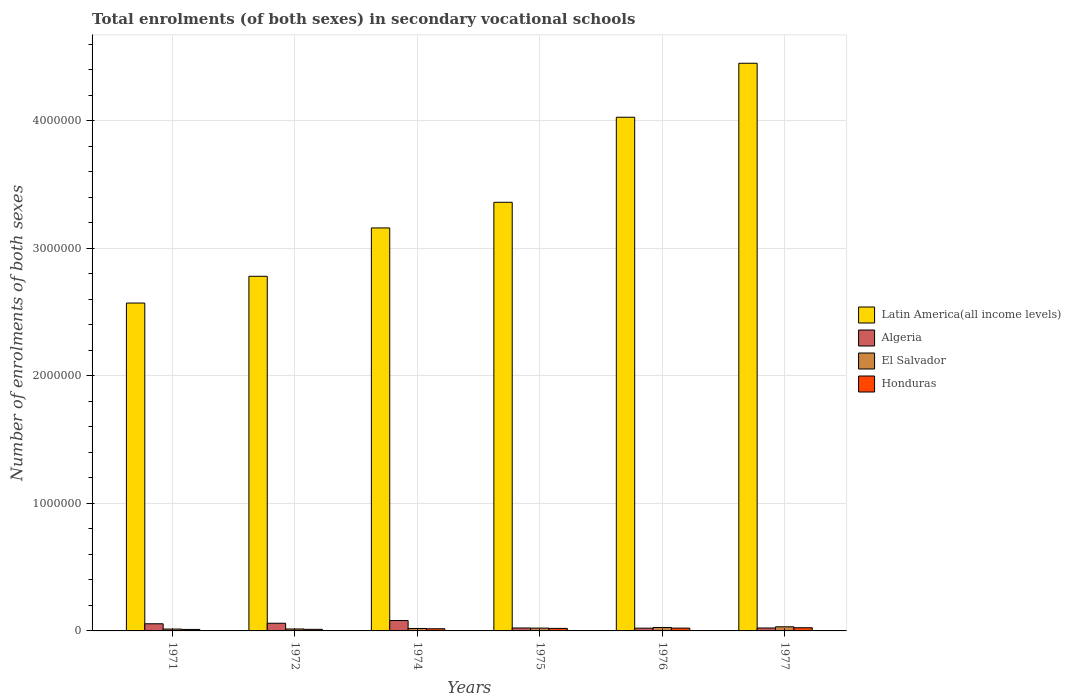How many groups of bars are there?
Your answer should be very brief. 6. How many bars are there on the 4th tick from the left?
Your answer should be compact. 4. What is the label of the 6th group of bars from the left?
Your response must be concise. 1977. In how many cases, is the number of bars for a given year not equal to the number of legend labels?
Keep it short and to the point. 0. What is the number of enrolments in secondary schools in Algeria in 1974?
Make the answer very short. 8.15e+04. Across all years, what is the maximum number of enrolments in secondary schools in El Salvador?
Provide a short and direct response. 3.22e+04. Across all years, what is the minimum number of enrolments in secondary schools in Honduras?
Keep it short and to the point. 1.16e+04. In which year was the number of enrolments in secondary schools in El Salvador maximum?
Make the answer very short. 1977. In which year was the number of enrolments in secondary schools in Honduras minimum?
Your answer should be compact. 1971. What is the total number of enrolments in secondary schools in Latin America(all income levels) in the graph?
Make the answer very short. 2.04e+07. What is the difference between the number of enrolments in secondary schools in Algeria in 1975 and that in 1976?
Your answer should be compact. 1509. What is the difference between the number of enrolments in secondary schools in Latin America(all income levels) in 1975 and the number of enrolments in secondary schools in Honduras in 1974?
Ensure brevity in your answer.  3.34e+06. What is the average number of enrolments in secondary schools in Honduras per year?
Offer a very short reply. 1.80e+04. In the year 1975, what is the difference between the number of enrolments in secondary schools in Honduras and number of enrolments in secondary schools in Latin America(all income levels)?
Your answer should be very brief. -3.34e+06. What is the ratio of the number of enrolments in secondary schools in Honduras in 1972 to that in 1977?
Give a very brief answer. 0.5. Is the difference between the number of enrolments in secondary schools in Honduras in 1972 and 1976 greater than the difference between the number of enrolments in secondary schools in Latin America(all income levels) in 1972 and 1976?
Offer a terse response. Yes. What is the difference between the highest and the second highest number of enrolments in secondary schools in Honduras?
Your response must be concise. 2913. What is the difference between the highest and the lowest number of enrolments in secondary schools in El Salvador?
Keep it short and to the point. 1.76e+04. Is the sum of the number of enrolments in secondary schools in Honduras in 1974 and 1976 greater than the maximum number of enrolments in secondary schools in El Salvador across all years?
Keep it short and to the point. Yes. What does the 2nd bar from the left in 1976 represents?
Your response must be concise. Algeria. What does the 2nd bar from the right in 1972 represents?
Offer a terse response. El Salvador. Is it the case that in every year, the sum of the number of enrolments in secondary schools in Latin America(all income levels) and number of enrolments in secondary schools in Algeria is greater than the number of enrolments in secondary schools in Honduras?
Your answer should be very brief. Yes. How many years are there in the graph?
Offer a terse response. 6. Are the values on the major ticks of Y-axis written in scientific E-notation?
Your answer should be very brief. No. Where does the legend appear in the graph?
Provide a succinct answer. Center right. How are the legend labels stacked?
Make the answer very short. Vertical. What is the title of the graph?
Offer a terse response. Total enrolments (of both sexes) in secondary vocational schools. Does "Lao PDR" appear as one of the legend labels in the graph?
Give a very brief answer. No. What is the label or title of the Y-axis?
Ensure brevity in your answer.  Number of enrolments of both sexes. What is the Number of enrolments of both sexes in Latin America(all income levels) in 1971?
Provide a short and direct response. 2.57e+06. What is the Number of enrolments of both sexes in Algeria in 1971?
Make the answer very short. 5.61e+04. What is the Number of enrolments of both sexes of El Salvador in 1971?
Your answer should be very brief. 1.47e+04. What is the Number of enrolments of both sexes of Honduras in 1971?
Your answer should be very brief. 1.16e+04. What is the Number of enrolments of both sexes in Latin America(all income levels) in 1972?
Your answer should be compact. 2.78e+06. What is the Number of enrolments of both sexes in Algeria in 1972?
Offer a very short reply. 6.02e+04. What is the Number of enrolments of both sexes of El Salvador in 1972?
Offer a very short reply. 1.52e+04. What is the Number of enrolments of both sexes of Honduras in 1972?
Your response must be concise. 1.25e+04. What is the Number of enrolments of both sexes in Latin America(all income levels) in 1974?
Your answer should be very brief. 3.16e+06. What is the Number of enrolments of both sexes in Algeria in 1974?
Offer a terse response. 8.15e+04. What is the Number of enrolments of both sexes in El Salvador in 1974?
Give a very brief answer. 1.91e+04. What is the Number of enrolments of both sexes of Honduras in 1974?
Provide a succinct answer. 1.70e+04. What is the Number of enrolments of both sexes of Latin America(all income levels) in 1975?
Your answer should be very brief. 3.36e+06. What is the Number of enrolments of both sexes in Algeria in 1975?
Your answer should be very brief. 2.31e+04. What is the Number of enrolments of both sexes of El Salvador in 1975?
Make the answer very short. 2.22e+04. What is the Number of enrolments of both sexes in Honduras in 1975?
Provide a succinct answer. 1.97e+04. What is the Number of enrolments of both sexes of Latin America(all income levels) in 1976?
Give a very brief answer. 4.03e+06. What is the Number of enrolments of both sexes of Algeria in 1976?
Offer a terse response. 2.16e+04. What is the Number of enrolments of both sexes of El Salvador in 1976?
Your answer should be compact. 2.66e+04. What is the Number of enrolments of both sexes of Honduras in 1976?
Offer a terse response. 2.20e+04. What is the Number of enrolments of both sexes of Latin America(all income levels) in 1977?
Offer a terse response. 4.45e+06. What is the Number of enrolments of both sexes of Algeria in 1977?
Make the answer very short. 2.30e+04. What is the Number of enrolments of both sexes in El Salvador in 1977?
Offer a very short reply. 3.22e+04. What is the Number of enrolments of both sexes in Honduras in 1977?
Your answer should be compact. 2.49e+04. Across all years, what is the maximum Number of enrolments of both sexes of Latin America(all income levels)?
Keep it short and to the point. 4.45e+06. Across all years, what is the maximum Number of enrolments of both sexes of Algeria?
Your answer should be compact. 8.15e+04. Across all years, what is the maximum Number of enrolments of both sexes in El Salvador?
Give a very brief answer. 3.22e+04. Across all years, what is the maximum Number of enrolments of both sexes in Honduras?
Offer a terse response. 2.49e+04. Across all years, what is the minimum Number of enrolments of both sexes of Latin America(all income levels)?
Keep it short and to the point. 2.57e+06. Across all years, what is the minimum Number of enrolments of both sexes in Algeria?
Offer a terse response. 2.16e+04. Across all years, what is the minimum Number of enrolments of both sexes of El Salvador?
Make the answer very short. 1.47e+04. Across all years, what is the minimum Number of enrolments of both sexes of Honduras?
Give a very brief answer. 1.16e+04. What is the total Number of enrolments of both sexes in Latin America(all income levels) in the graph?
Your response must be concise. 2.04e+07. What is the total Number of enrolments of both sexes in Algeria in the graph?
Your response must be concise. 2.66e+05. What is the total Number of enrolments of both sexes of El Salvador in the graph?
Your answer should be very brief. 1.30e+05. What is the total Number of enrolments of both sexes in Honduras in the graph?
Make the answer very short. 1.08e+05. What is the difference between the Number of enrolments of both sexes in Latin America(all income levels) in 1971 and that in 1972?
Provide a succinct answer. -2.10e+05. What is the difference between the Number of enrolments of both sexes in Algeria in 1971 and that in 1972?
Provide a succinct answer. -4174. What is the difference between the Number of enrolments of both sexes of El Salvador in 1971 and that in 1972?
Keep it short and to the point. -527. What is the difference between the Number of enrolments of both sexes of Honduras in 1971 and that in 1972?
Offer a terse response. -825. What is the difference between the Number of enrolments of both sexes in Latin America(all income levels) in 1971 and that in 1974?
Your response must be concise. -5.89e+05. What is the difference between the Number of enrolments of both sexes of Algeria in 1971 and that in 1974?
Provide a succinct answer. -2.54e+04. What is the difference between the Number of enrolments of both sexes in El Salvador in 1971 and that in 1974?
Provide a short and direct response. -4484. What is the difference between the Number of enrolments of both sexes of Honduras in 1971 and that in 1974?
Ensure brevity in your answer.  -5352. What is the difference between the Number of enrolments of both sexes in Latin America(all income levels) in 1971 and that in 1975?
Keep it short and to the point. -7.90e+05. What is the difference between the Number of enrolments of both sexes of Algeria in 1971 and that in 1975?
Make the answer very short. 3.30e+04. What is the difference between the Number of enrolments of both sexes of El Salvador in 1971 and that in 1975?
Provide a succinct answer. -7507. What is the difference between the Number of enrolments of both sexes in Honduras in 1971 and that in 1975?
Provide a short and direct response. -8106. What is the difference between the Number of enrolments of both sexes in Latin America(all income levels) in 1971 and that in 1976?
Ensure brevity in your answer.  -1.46e+06. What is the difference between the Number of enrolments of both sexes of Algeria in 1971 and that in 1976?
Offer a very short reply. 3.45e+04. What is the difference between the Number of enrolments of both sexes of El Salvador in 1971 and that in 1976?
Keep it short and to the point. -1.20e+04. What is the difference between the Number of enrolments of both sexes in Honduras in 1971 and that in 1976?
Offer a terse response. -1.03e+04. What is the difference between the Number of enrolments of both sexes of Latin America(all income levels) in 1971 and that in 1977?
Your response must be concise. -1.88e+06. What is the difference between the Number of enrolments of both sexes in Algeria in 1971 and that in 1977?
Ensure brevity in your answer.  3.31e+04. What is the difference between the Number of enrolments of both sexes of El Salvador in 1971 and that in 1977?
Ensure brevity in your answer.  -1.76e+04. What is the difference between the Number of enrolments of both sexes in Honduras in 1971 and that in 1977?
Offer a terse response. -1.33e+04. What is the difference between the Number of enrolments of both sexes in Latin America(all income levels) in 1972 and that in 1974?
Your answer should be very brief. -3.79e+05. What is the difference between the Number of enrolments of both sexes in Algeria in 1972 and that in 1974?
Keep it short and to the point. -2.12e+04. What is the difference between the Number of enrolments of both sexes in El Salvador in 1972 and that in 1974?
Offer a terse response. -3957. What is the difference between the Number of enrolments of both sexes in Honduras in 1972 and that in 1974?
Give a very brief answer. -4527. What is the difference between the Number of enrolments of both sexes in Latin America(all income levels) in 1972 and that in 1975?
Make the answer very short. -5.80e+05. What is the difference between the Number of enrolments of both sexes in Algeria in 1972 and that in 1975?
Make the answer very short. 3.71e+04. What is the difference between the Number of enrolments of both sexes of El Salvador in 1972 and that in 1975?
Keep it short and to the point. -6980. What is the difference between the Number of enrolments of both sexes of Honduras in 1972 and that in 1975?
Provide a short and direct response. -7281. What is the difference between the Number of enrolments of both sexes of Latin America(all income levels) in 1972 and that in 1976?
Your answer should be compact. -1.25e+06. What is the difference between the Number of enrolments of both sexes of Algeria in 1972 and that in 1976?
Offer a very short reply. 3.86e+04. What is the difference between the Number of enrolments of both sexes of El Salvador in 1972 and that in 1976?
Make the answer very short. -1.14e+04. What is the difference between the Number of enrolments of both sexes in Honduras in 1972 and that in 1976?
Give a very brief answer. -9518. What is the difference between the Number of enrolments of both sexes of Latin America(all income levels) in 1972 and that in 1977?
Provide a succinct answer. -1.67e+06. What is the difference between the Number of enrolments of both sexes of Algeria in 1972 and that in 1977?
Give a very brief answer. 3.72e+04. What is the difference between the Number of enrolments of both sexes of El Salvador in 1972 and that in 1977?
Offer a terse response. -1.70e+04. What is the difference between the Number of enrolments of both sexes in Honduras in 1972 and that in 1977?
Keep it short and to the point. -1.24e+04. What is the difference between the Number of enrolments of both sexes in Latin America(all income levels) in 1974 and that in 1975?
Ensure brevity in your answer.  -2.01e+05. What is the difference between the Number of enrolments of both sexes in Algeria in 1974 and that in 1975?
Your response must be concise. 5.84e+04. What is the difference between the Number of enrolments of both sexes in El Salvador in 1974 and that in 1975?
Make the answer very short. -3023. What is the difference between the Number of enrolments of both sexes of Honduras in 1974 and that in 1975?
Ensure brevity in your answer.  -2754. What is the difference between the Number of enrolments of both sexes of Latin America(all income levels) in 1974 and that in 1976?
Offer a very short reply. -8.68e+05. What is the difference between the Number of enrolments of both sexes of Algeria in 1974 and that in 1976?
Keep it short and to the point. 5.99e+04. What is the difference between the Number of enrolments of both sexes of El Salvador in 1974 and that in 1976?
Give a very brief answer. -7481. What is the difference between the Number of enrolments of both sexes in Honduras in 1974 and that in 1976?
Ensure brevity in your answer.  -4991. What is the difference between the Number of enrolments of both sexes in Latin America(all income levels) in 1974 and that in 1977?
Give a very brief answer. -1.29e+06. What is the difference between the Number of enrolments of both sexes in Algeria in 1974 and that in 1977?
Provide a short and direct response. 5.85e+04. What is the difference between the Number of enrolments of both sexes of El Salvador in 1974 and that in 1977?
Your answer should be compact. -1.31e+04. What is the difference between the Number of enrolments of both sexes of Honduras in 1974 and that in 1977?
Keep it short and to the point. -7904. What is the difference between the Number of enrolments of both sexes in Latin America(all income levels) in 1975 and that in 1976?
Your answer should be very brief. -6.67e+05. What is the difference between the Number of enrolments of both sexes in Algeria in 1975 and that in 1976?
Ensure brevity in your answer.  1509. What is the difference between the Number of enrolments of both sexes in El Salvador in 1975 and that in 1976?
Keep it short and to the point. -4458. What is the difference between the Number of enrolments of both sexes in Honduras in 1975 and that in 1976?
Your answer should be very brief. -2237. What is the difference between the Number of enrolments of both sexes in Latin America(all income levels) in 1975 and that in 1977?
Give a very brief answer. -1.09e+06. What is the difference between the Number of enrolments of both sexes in Algeria in 1975 and that in 1977?
Keep it short and to the point. 117. What is the difference between the Number of enrolments of both sexes of El Salvador in 1975 and that in 1977?
Your response must be concise. -1.01e+04. What is the difference between the Number of enrolments of both sexes of Honduras in 1975 and that in 1977?
Give a very brief answer. -5150. What is the difference between the Number of enrolments of both sexes of Latin America(all income levels) in 1976 and that in 1977?
Provide a succinct answer. -4.23e+05. What is the difference between the Number of enrolments of both sexes in Algeria in 1976 and that in 1977?
Your answer should be very brief. -1392. What is the difference between the Number of enrolments of both sexes of El Salvador in 1976 and that in 1977?
Your answer should be compact. -5599. What is the difference between the Number of enrolments of both sexes in Honduras in 1976 and that in 1977?
Provide a succinct answer. -2913. What is the difference between the Number of enrolments of both sexes in Latin America(all income levels) in 1971 and the Number of enrolments of both sexes in Algeria in 1972?
Give a very brief answer. 2.51e+06. What is the difference between the Number of enrolments of both sexes of Latin America(all income levels) in 1971 and the Number of enrolments of both sexes of El Salvador in 1972?
Offer a very short reply. 2.56e+06. What is the difference between the Number of enrolments of both sexes in Latin America(all income levels) in 1971 and the Number of enrolments of both sexes in Honduras in 1972?
Offer a very short reply. 2.56e+06. What is the difference between the Number of enrolments of both sexes in Algeria in 1971 and the Number of enrolments of both sexes in El Salvador in 1972?
Keep it short and to the point. 4.09e+04. What is the difference between the Number of enrolments of both sexes of Algeria in 1971 and the Number of enrolments of both sexes of Honduras in 1972?
Your answer should be very brief. 4.36e+04. What is the difference between the Number of enrolments of both sexes of El Salvador in 1971 and the Number of enrolments of both sexes of Honduras in 1972?
Offer a terse response. 2197. What is the difference between the Number of enrolments of both sexes of Latin America(all income levels) in 1971 and the Number of enrolments of both sexes of Algeria in 1974?
Provide a succinct answer. 2.49e+06. What is the difference between the Number of enrolments of both sexes in Latin America(all income levels) in 1971 and the Number of enrolments of both sexes in El Salvador in 1974?
Your answer should be compact. 2.55e+06. What is the difference between the Number of enrolments of both sexes of Latin America(all income levels) in 1971 and the Number of enrolments of both sexes of Honduras in 1974?
Give a very brief answer. 2.55e+06. What is the difference between the Number of enrolments of both sexes in Algeria in 1971 and the Number of enrolments of both sexes in El Salvador in 1974?
Provide a succinct answer. 3.69e+04. What is the difference between the Number of enrolments of both sexes of Algeria in 1971 and the Number of enrolments of both sexes of Honduras in 1974?
Your answer should be compact. 3.91e+04. What is the difference between the Number of enrolments of both sexes of El Salvador in 1971 and the Number of enrolments of both sexes of Honduras in 1974?
Your answer should be very brief. -2330. What is the difference between the Number of enrolments of both sexes in Latin America(all income levels) in 1971 and the Number of enrolments of both sexes in Algeria in 1975?
Keep it short and to the point. 2.55e+06. What is the difference between the Number of enrolments of both sexes in Latin America(all income levels) in 1971 and the Number of enrolments of both sexes in El Salvador in 1975?
Make the answer very short. 2.55e+06. What is the difference between the Number of enrolments of both sexes of Latin America(all income levels) in 1971 and the Number of enrolments of both sexes of Honduras in 1975?
Ensure brevity in your answer.  2.55e+06. What is the difference between the Number of enrolments of both sexes of Algeria in 1971 and the Number of enrolments of both sexes of El Salvador in 1975?
Your answer should be very brief. 3.39e+04. What is the difference between the Number of enrolments of both sexes of Algeria in 1971 and the Number of enrolments of both sexes of Honduras in 1975?
Provide a short and direct response. 3.63e+04. What is the difference between the Number of enrolments of both sexes of El Salvador in 1971 and the Number of enrolments of both sexes of Honduras in 1975?
Offer a terse response. -5084. What is the difference between the Number of enrolments of both sexes in Latin America(all income levels) in 1971 and the Number of enrolments of both sexes in Algeria in 1976?
Provide a succinct answer. 2.55e+06. What is the difference between the Number of enrolments of both sexes of Latin America(all income levels) in 1971 and the Number of enrolments of both sexes of El Salvador in 1976?
Your answer should be compact. 2.54e+06. What is the difference between the Number of enrolments of both sexes of Latin America(all income levels) in 1971 and the Number of enrolments of both sexes of Honduras in 1976?
Your answer should be compact. 2.55e+06. What is the difference between the Number of enrolments of both sexes of Algeria in 1971 and the Number of enrolments of both sexes of El Salvador in 1976?
Your response must be concise. 2.94e+04. What is the difference between the Number of enrolments of both sexes in Algeria in 1971 and the Number of enrolments of both sexes in Honduras in 1976?
Offer a terse response. 3.41e+04. What is the difference between the Number of enrolments of both sexes of El Salvador in 1971 and the Number of enrolments of both sexes of Honduras in 1976?
Ensure brevity in your answer.  -7321. What is the difference between the Number of enrolments of both sexes in Latin America(all income levels) in 1971 and the Number of enrolments of both sexes in Algeria in 1977?
Offer a terse response. 2.55e+06. What is the difference between the Number of enrolments of both sexes of Latin America(all income levels) in 1971 and the Number of enrolments of both sexes of El Salvador in 1977?
Offer a very short reply. 2.54e+06. What is the difference between the Number of enrolments of both sexes in Latin America(all income levels) in 1971 and the Number of enrolments of both sexes in Honduras in 1977?
Your response must be concise. 2.55e+06. What is the difference between the Number of enrolments of both sexes in Algeria in 1971 and the Number of enrolments of both sexes in El Salvador in 1977?
Offer a very short reply. 2.38e+04. What is the difference between the Number of enrolments of both sexes in Algeria in 1971 and the Number of enrolments of both sexes in Honduras in 1977?
Make the answer very short. 3.12e+04. What is the difference between the Number of enrolments of both sexes of El Salvador in 1971 and the Number of enrolments of both sexes of Honduras in 1977?
Your response must be concise. -1.02e+04. What is the difference between the Number of enrolments of both sexes in Latin America(all income levels) in 1972 and the Number of enrolments of both sexes in Algeria in 1974?
Your response must be concise. 2.70e+06. What is the difference between the Number of enrolments of both sexes in Latin America(all income levels) in 1972 and the Number of enrolments of both sexes in El Salvador in 1974?
Offer a very short reply. 2.76e+06. What is the difference between the Number of enrolments of both sexes in Latin America(all income levels) in 1972 and the Number of enrolments of both sexes in Honduras in 1974?
Offer a very short reply. 2.76e+06. What is the difference between the Number of enrolments of both sexes of Algeria in 1972 and the Number of enrolments of both sexes of El Salvador in 1974?
Offer a very short reply. 4.11e+04. What is the difference between the Number of enrolments of both sexes of Algeria in 1972 and the Number of enrolments of both sexes of Honduras in 1974?
Provide a short and direct response. 4.33e+04. What is the difference between the Number of enrolments of both sexes of El Salvador in 1972 and the Number of enrolments of both sexes of Honduras in 1974?
Your answer should be compact. -1803. What is the difference between the Number of enrolments of both sexes in Latin America(all income levels) in 1972 and the Number of enrolments of both sexes in Algeria in 1975?
Ensure brevity in your answer.  2.76e+06. What is the difference between the Number of enrolments of both sexes in Latin America(all income levels) in 1972 and the Number of enrolments of both sexes in El Salvador in 1975?
Make the answer very short. 2.76e+06. What is the difference between the Number of enrolments of both sexes in Latin America(all income levels) in 1972 and the Number of enrolments of both sexes in Honduras in 1975?
Provide a short and direct response. 2.76e+06. What is the difference between the Number of enrolments of both sexes in Algeria in 1972 and the Number of enrolments of both sexes in El Salvador in 1975?
Ensure brevity in your answer.  3.81e+04. What is the difference between the Number of enrolments of both sexes of Algeria in 1972 and the Number of enrolments of both sexes of Honduras in 1975?
Keep it short and to the point. 4.05e+04. What is the difference between the Number of enrolments of both sexes of El Salvador in 1972 and the Number of enrolments of both sexes of Honduras in 1975?
Your answer should be compact. -4557. What is the difference between the Number of enrolments of both sexes in Latin America(all income levels) in 1972 and the Number of enrolments of both sexes in Algeria in 1976?
Offer a very short reply. 2.76e+06. What is the difference between the Number of enrolments of both sexes in Latin America(all income levels) in 1972 and the Number of enrolments of both sexes in El Salvador in 1976?
Provide a succinct answer. 2.75e+06. What is the difference between the Number of enrolments of both sexes in Latin America(all income levels) in 1972 and the Number of enrolments of both sexes in Honduras in 1976?
Ensure brevity in your answer.  2.76e+06. What is the difference between the Number of enrolments of both sexes in Algeria in 1972 and the Number of enrolments of both sexes in El Salvador in 1976?
Offer a very short reply. 3.36e+04. What is the difference between the Number of enrolments of both sexes of Algeria in 1972 and the Number of enrolments of both sexes of Honduras in 1976?
Offer a very short reply. 3.83e+04. What is the difference between the Number of enrolments of both sexes in El Salvador in 1972 and the Number of enrolments of both sexes in Honduras in 1976?
Your response must be concise. -6794. What is the difference between the Number of enrolments of both sexes in Latin America(all income levels) in 1972 and the Number of enrolments of both sexes in Algeria in 1977?
Give a very brief answer. 2.76e+06. What is the difference between the Number of enrolments of both sexes of Latin America(all income levels) in 1972 and the Number of enrolments of both sexes of El Salvador in 1977?
Offer a very short reply. 2.75e+06. What is the difference between the Number of enrolments of both sexes in Latin America(all income levels) in 1972 and the Number of enrolments of both sexes in Honduras in 1977?
Your answer should be compact. 2.76e+06. What is the difference between the Number of enrolments of both sexes of Algeria in 1972 and the Number of enrolments of both sexes of El Salvador in 1977?
Offer a very short reply. 2.80e+04. What is the difference between the Number of enrolments of both sexes in Algeria in 1972 and the Number of enrolments of both sexes in Honduras in 1977?
Provide a short and direct response. 3.53e+04. What is the difference between the Number of enrolments of both sexes of El Salvador in 1972 and the Number of enrolments of both sexes of Honduras in 1977?
Provide a short and direct response. -9707. What is the difference between the Number of enrolments of both sexes of Latin America(all income levels) in 1974 and the Number of enrolments of both sexes of Algeria in 1975?
Ensure brevity in your answer.  3.14e+06. What is the difference between the Number of enrolments of both sexes in Latin America(all income levels) in 1974 and the Number of enrolments of both sexes in El Salvador in 1975?
Your answer should be compact. 3.14e+06. What is the difference between the Number of enrolments of both sexes in Latin America(all income levels) in 1974 and the Number of enrolments of both sexes in Honduras in 1975?
Make the answer very short. 3.14e+06. What is the difference between the Number of enrolments of both sexes in Algeria in 1974 and the Number of enrolments of both sexes in El Salvador in 1975?
Make the answer very short. 5.93e+04. What is the difference between the Number of enrolments of both sexes in Algeria in 1974 and the Number of enrolments of both sexes in Honduras in 1975?
Make the answer very short. 6.17e+04. What is the difference between the Number of enrolments of both sexes of El Salvador in 1974 and the Number of enrolments of both sexes of Honduras in 1975?
Your answer should be compact. -600. What is the difference between the Number of enrolments of both sexes of Latin America(all income levels) in 1974 and the Number of enrolments of both sexes of Algeria in 1976?
Your answer should be compact. 3.14e+06. What is the difference between the Number of enrolments of both sexes of Latin America(all income levels) in 1974 and the Number of enrolments of both sexes of El Salvador in 1976?
Give a very brief answer. 3.13e+06. What is the difference between the Number of enrolments of both sexes in Latin America(all income levels) in 1974 and the Number of enrolments of both sexes in Honduras in 1976?
Your answer should be very brief. 3.14e+06. What is the difference between the Number of enrolments of both sexes in Algeria in 1974 and the Number of enrolments of both sexes in El Salvador in 1976?
Provide a succinct answer. 5.49e+04. What is the difference between the Number of enrolments of both sexes in Algeria in 1974 and the Number of enrolments of both sexes in Honduras in 1976?
Make the answer very short. 5.95e+04. What is the difference between the Number of enrolments of both sexes in El Salvador in 1974 and the Number of enrolments of both sexes in Honduras in 1976?
Give a very brief answer. -2837. What is the difference between the Number of enrolments of both sexes in Latin America(all income levels) in 1974 and the Number of enrolments of both sexes in Algeria in 1977?
Offer a terse response. 3.14e+06. What is the difference between the Number of enrolments of both sexes in Latin America(all income levels) in 1974 and the Number of enrolments of both sexes in El Salvador in 1977?
Offer a very short reply. 3.13e+06. What is the difference between the Number of enrolments of both sexes in Latin America(all income levels) in 1974 and the Number of enrolments of both sexes in Honduras in 1977?
Ensure brevity in your answer.  3.14e+06. What is the difference between the Number of enrolments of both sexes in Algeria in 1974 and the Number of enrolments of both sexes in El Salvador in 1977?
Give a very brief answer. 4.93e+04. What is the difference between the Number of enrolments of both sexes in Algeria in 1974 and the Number of enrolments of both sexes in Honduras in 1977?
Offer a very short reply. 5.66e+04. What is the difference between the Number of enrolments of both sexes in El Salvador in 1974 and the Number of enrolments of both sexes in Honduras in 1977?
Give a very brief answer. -5750. What is the difference between the Number of enrolments of both sexes of Latin America(all income levels) in 1975 and the Number of enrolments of both sexes of Algeria in 1976?
Make the answer very short. 3.34e+06. What is the difference between the Number of enrolments of both sexes of Latin America(all income levels) in 1975 and the Number of enrolments of both sexes of El Salvador in 1976?
Offer a very short reply. 3.33e+06. What is the difference between the Number of enrolments of both sexes of Latin America(all income levels) in 1975 and the Number of enrolments of both sexes of Honduras in 1976?
Your answer should be very brief. 3.34e+06. What is the difference between the Number of enrolments of both sexes of Algeria in 1975 and the Number of enrolments of both sexes of El Salvador in 1976?
Keep it short and to the point. -3511. What is the difference between the Number of enrolments of both sexes of Algeria in 1975 and the Number of enrolments of both sexes of Honduras in 1976?
Give a very brief answer. 1133. What is the difference between the Number of enrolments of both sexes in El Salvador in 1975 and the Number of enrolments of both sexes in Honduras in 1976?
Offer a terse response. 186. What is the difference between the Number of enrolments of both sexes in Latin America(all income levels) in 1975 and the Number of enrolments of both sexes in Algeria in 1977?
Your answer should be very brief. 3.34e+06. What is the difference between the Number of enrolments of both sexes of Latin America(all income levels) in 1975 and the Number of enrolments of both sexes of El Salvador in 1977?
Offer a terse response. 3.33e+06. What is the difference between the Number of enrolments of both sexes in Latin America(all income levels) in 1975 and the Number of enrolments of both sexes in Honduras in 1977?
Give a very brief answer. 3.34e+06. What is the difference between the Number of enrolments of both sexes in Algeria in 1975 and the Number of enrolments of both sexes in El Salvador in 1977?
Your response must be concise. -9110. What is the difference between the Number of enrolments of both sexes in Algeria in 1975 and the Number of enrolments of both sexes in Honduras in 1977?
Offer a terse response. -1780. What is the difference between the Number of enrolments of both sexes in El Salvador in 1975 and the Number of enrolments of both sexes in Honduras in 1977?
Your answer should be very brief. -2727. What is the difference between the Number of enrolments of both sexes in Latin America(all income levels) in 1976 and the Number of enrolments of both sexes in Algeria in 1977?
Make the answer very short. 4.01e+06. What is the difference between the Number of enrolments of both sexes in Latin America(all income levels) in 1976 and the Number of enrolments of both sexes in El Salvador in 1977?
Your answer should be very brief. 4.00e+06. What is the difference between the Number of enrolments of both sexes of Latin America(all income levels) in 1976 and the Number of enrolments of both sexes of Honduras in 1977?
Keep it short and to the point. 4.00e+06. What is the difference between the Number of enrolments of both sexes in Algeria in 1976 and the Number of enrolments of both sexes in El Salvador in 1977?
Offer a terse response. -1.06e+04. What is the difference between the Number of enrolments of both sexes of Algeria in 1976 and the Number of enrolments of both sexes of Honduras in 1977?
Offer a very short reply. -3289. What is the difference between the Number of enrolments of both sexes in El Salvador in 1976 and the Number of enrolments of both sexes in Honduras in 1977?
Offer a terse response. 1731. What is the average Number of enrolments of both sexes in Latin America(all income levels) per year?
Your response must be concise. 3.39e+06. What is the average Number of enrolments of both sexes in Algeria per year?
Your response must be concise. 4.43e+04. What is the average Number of enrolments of both sexes in El Salvador per year?
Offer a very short reply. 2.17e+04. What is the average Number of enrolments of both sexes of Honduras per year?
Keep it short and to the point. 1.80e+04. In the year 1971, what is the difference between the Number of enrolments of both sexes in Latin America(all income levels) and Number of enrolments of both sexes in Algeria?
Give a very brief answer. 2.52e+06. In the year 1971, what is the difference between the Number of enrolments of both sexes in Latin America(all income levels) and Number of enrolments of both sexes in El Salvador?
Your response must be concise. 2.56e+06. In the year 1971, what is the difference between the Number of enrolments of both sexes in Latin America(all income levels) and Number of enrolments of both sexes in Honduras?
Ensure brevity in your answer.  2.56e+06. In the year 1971, what is the difference between the Number of enrolments of both sexes of Algeria and Number of enrolments of both sexes of El Salvador?
Your answer should be very brief. 4.14e+04. In the year 1971, what is the difference between the Number of enrolments of both sexes of Algeria and Number of enrolments of both sexes of Honduras?
Ensure brevity in your answer.  4.44e+04. In the year 1971, what is the difference between the Number of enrolments of both sexes in El Salvador and Number of enrolments of both sexes in Honduras?
Your response must be concise. 3022. In the year 1972, what is the difference between the Number of enrolments of both sexes of Latin America(all income levels) and Number of enrolments of both sexes of Algeria?
Keep it short and to the point. 2.72e+06. In the year 1972, what is the difference between the Number of enrolments of both sexes in Latin America(all income levels) and Number of enrolments of both sexes in El Salvador?
Offer a terse response. 2.77e+06. In the year 1972, what is the difference between the Number of enrolments of both sexes of Latin America(all income levels) and Number of enrolments of both sexes of Honduras?
Your answer should be very brief. 2.77e+06. In the year 1972, what is the difference between the Number of enrolments of both sexes in Algeria and Number of enrolments of both sexes in El Salvador?
Give a very brief answer. 4.51e+04. In the year 1972, what is the difference between the Number of enrolments of both sexes of Algeria and Number of enrolments of both sexes of Honduras?
Your response must be concise. 4.78e+04. In the year 1972, what is the difference between the Number of enrolments of both sexes of El Salvador and Number of enrolments of both sexes of Honduras?
Your answer should be compact. 2724. In the year 1974, what is the difference between the Number of enrolments of both sexes in Latin America(all income levels) and Number of enrolments of both sexes in Algeria?
Give a very brief answer. 3.08e+06. In the year 1974, what is the difference between the Number of enrolments of both sexes of Latin America(all income levels) and Number of enrolments of both sexes of El Salvador?
Provide a short and direct response. 3.14e+06. In the year 1974, what is the difference between the Number of enrolments of both sexes of Latin America(all income levels) and Number of enrolments of both sexes of Honduras?
Provide a succinct answer. 3.14e+06. In the year 1974, what is the difference between the Number of enrolments of both sexes in Algeria and Number of enrolments of both sexes in El Salvador?
Your answer should be very brief. 6.23e+04. In the year 1974, what is the difference between the Number of enrolments of both sexes of Algeria and Number of enrolments of both sexes of Honduras?
Provide a short and direct response. 6.45e+04. In the year 1974, what is the difference between the Number of enrolments of both sexes in El Salvador and Number of enrolments of both sexes in Honduras?
Make the answer very short. 2154. In the year 1975, what is the difference between the Number of enrolments of both sexes of Latin America(all income levels) and Number of enrolments of both sexes of Algeria?
Offer a very short reply. 3.34e+06. In the year 1975, what is the difference between the Number of enrolments of both sexes of Latin America(all income levels) and Number of enrolments of both sexes of El Salvador?
Provide a succinct answer. 3.34e+06. In the year 1975, what is the difference between the Number of enrolments of both sexes in Latin America(all income levels) and Number of enrolments of both sexes in Honduras?
Provide a succinct answer. 3.34e+06. In the year 1975, what is the difference between the Number of enrolments of both sexes of Algeria and Number of enrolments of both sexes of El Salvador?
Offer a terse response. 947. In the year 1975, what is the difference between the Number of enrolments of both sexes of Algeria and Number of enrolments of both sexes of Honduras?
Provide a short and direct response. 3370. In the year 1975, what is the difference between the Number of enrolments of both sexes of El Salvador and Number of enrolments of both sexes of Honduras?
Provide a short and direct response. 2423. In the year 1976, what is the difference between the Number of enrolments of both sexes in Latin America(all income levels) and Number of enrolments of both sexes in Algeria?
Offer a very short reply. 4.01e+06. In the year 1976, what is the difference between the Number of enrolments of both sexes of Latin America(all income levels) and Number of enrolments of both sexes of El Salvador?
Your response must be concise. 4.00e+06. In the year 1976, what is the difference between the Number of enrolments of both sexes in Latin America(all income levels) and Number of enrolments of both sexes in Honduras?
Give a very brief answer. 4.01e+06. In the year 1976, what is the difference between the Number of enrolments of both sexes of Algeria and Number of enrolments of both sexes of El Salvador?
Your answer should be very brief. -5020. In the year 1976, what is the difference between the Number of enrolments of both sexes of Algeria and Number of enrolments of both sexes of Honduras?
Provide a succinct answer. -376. In the year 1976, what is the difference between the Number of enrolments of both sexes in El Salvador and Number of enrolments of both sexes in Honduras?
Give a very brief answer. 4644. In the year 1977, what is the difference between the Number of enrolments of both sexes of Latin America(all income levels) and Number of enrolments of both sexes of Algeria?
Ensure brevity in your answer.  4.43e+06. In the year 1977, what is the difference between the Number of enrolments of both sexes of Latin America(all income levels) and Number of enrolments of both sexes of El Salvador?
Offer a very short reply. 4.42e+06. In the year 1977, what is the difference between the Number of enrolments of both sexes in Latin America(all income levels) and Number of enrolments of both sexes in Honduras?
Your answer should be compact. 4.43e+06. In the year 1977, what is the difference between the Number of enrolments of both sexes of Algeria and Number of enrolments of both sexes of El Salvador?
Provide a succinct answer. -9227. In the year 1977, what is the difference between the Number of enrolments of both sexes in Algeria and Number of enrolments of both sexes in Honduras?
Your answer should be compact. -1897. In the year 1977, what is the difference between the Number of enrolments of both sexes of El Salvador and Number of enrolments of both sexes of Honduras?
Your answer should be very brief. 7330. What is the ratio of the Number of enrolments of both sexes of Latin America(all income levels) in 1971 to that in 1972?
Ensure brevity in your answer.  0.92. What is the ratio of the Number of enrolments of both sexes in Algeria in 1971 to that in 1972?
Keep it short and to the point. 0.93. What is the ratio of the Number of enrolments of both sexes in El Salvador in 1971 to that in 1972?
Your answer should be compact. 0.97. What is the ratio of the Number of enrolments of both sexes of Honduras in 1971 to that in 1972?
Your answer should be very brief. 0.93. What is the ratio of the Number of enrolments of both sexes of Latin America(all income levels) in 1971 to that in 1974?
Your response must be concise. 0.81. What is the ratio of the Number of enrolments of both sexes in Algeria in 1971 to that in 1974?
Provide a succinct answer. 0.69. What is the ratio of the Number of enrolments of both sexes in El Salvador in 1971 to that in 1974?
Offer a terse response. 0.77. What is the ratio of the Number of enrolments of both sexes of Honduras in 1971 to that in 1974?
Ensure brevity in your answer.  0.69. What is the ratio of the Number of enrolments of both sexes of Latin America(all income levels) in 1971 to that in 1975?
Make the answer very short. 0.77. What is the ratio of the Number of enrolments of both sexes in Algeria in 1971 to that in 1975?
Offer a very short reply. 2.43. What is the ratio of the Number of enrolments of both sexes in El Salvador in 1971 to that in 1975?
Keep it short and to the point. 0.66. What is the ratio of the Number of enrolments of both sexes in Honduras in 1971 to that in 1975?
Provide a succinct answer. 0.59. What is the ratio of the Number of enrolments of both sexes of Latin America(all income levels) in 1971 to that in 1976?
Your answer should be compact. 0.64. What is the ratio of the Number of enrolments of both sexes in Algeria in 1971 to that in 1976?
Give a very brief answer. 2.59. What is the ratio of the Number of enrolments of both sexes of El Salvador in 1971 to that in 1976?
Provide a short and direct response. 0.55. What is the ratio of the Number of enrolments of both sexes in Honduras in 1971 to that in 1976?
Provide a succinct answer. 0.53. What is the ratio of the Number of enrolments of both sexes of Latin America(all income levels) in 1971 to that in 1977?
Offer a terse response. 0.58. What is the ratio of the Number of enrolments of both sexes in Algeria in 1971 to that in 1977?
Offer a very short reply. 2.44. What is the ratio of the Number of enrolments of both sexes of El Salvador in 1971 to that in 1977?
Make the answer very short. 0.46. What is the ratio of the Number of enrolments of both sexes in Honduras in 1971 to that in 1977?
Offer a very short reply. 0.47. What is the ratio of the Number of enrolments of both sexes of Latin America(all income levels) in 1972 to that in 1974?
Offer a very short reply. 0.88. What is the ratio of the Number of enrolments of both sexes in Algeria in 1972 to that in 1974?
Ensure brevity in your answer.  0.74. What is the ratio of the Number of enrolments of both sexes in El Salvador in 1972 to that in 1974?
Your answer should be compact. 0.79. What is the ratio of the Number of enrolments of both sexes in Honduras in 1972 to that in 1974?
Make the answer very short. 0.73. What is the ratio of the Number of enrolments of both sexes in Latin America(all income levels) in 1972 to that in 1975?
Ensure brevity in your answer.  0.83. What is the ratio of the Number of enrolments of both sexes in Algeria in 1972 to that in 1975?
Give a very brief answer. 2.61. What is the ratio of the Number of enrolments of both sexes of El Salvador in 1972 to that in 1975?
Provide a succinct answer. 0.69. What is the ratio of the Number of enrolments of both sexes of Honduras in 1972 to that in 1975?
Make the answer very short. 0.63. What is the ratio of the Number of enrolments of both sexes of Latin America(all income levels) in 1972 to that in 1976?
Offer a terse response. 0.69. What is the ratio of the Number of enrolments of both sexes in Algeria in 1972 to that in 1976?
Give a very brief answer. 2.79. What is the ratio of the Number of enrolments of both sexes of El Salvador in 1972 to that in 1976?
Your answer should be compact. 0.57. What is the ratio of the Number of enrolments of both sexes of Honduras in 1972 to that in 1976?
Your answer should be compact. 0.57. What is the ratio of the Number of enrolments of both sexes of Latin America(all income levels) in 1972 to that in 1977?
Offer a very short reply. 0.62. What is the ratio of the Number of enrolments of both sexes in Algeria in 1972 to that in 1977?
Your answer should be compact. 2.62. What is the ratio of the Number of enrolments of both sexes of El Salvador in 1972 to that in 1977?
Your answer should be compact. 0.47. What is the ratio of the Number of enrolments of both sexes of Honduras in 1972 to that in 1977?
Offer a very short reply. 0.5. What is the ratio of the Number of enrolments of both sexes of Latin America(all income levels) in 1974 to that in 1975?
Ensure brevity in your answer.  0.94. What is the ratio of the Number of enrolments of both sexes in Algeria in 1974 to that in 1975?
Make the answer very short. 3.52. What is the ratio of the Number of enrolments of both sexes of El Salvador in 1974 to that in 1975?
Make the answer very short. 0.86. What is the ratio of the Number of enrolments of both sexes of Honduras in 1974 to that in 1975?
Your response must be concise. 0.86. What is the ratio of the Number of enrolments of both sexes in Latin America(all income levels) in 1974 to that in 1976?
Provide a short and direct response. 0.78. What is the ratio of the Number of enrolments of both sexes in Algeria in 1974 to that in 1976?
Your response must be concise. 3.77. What is the ratio of the Number of enrolments of both sexes of El Salvador in 1974 to that in 1976?
Offer a terse response. 0.72. What is the ratio of the Number of enrolments of both sexes of Honduras in 1974 to that in 1976?
Your answer should be compact. 0.77. What is the ratio of the Number of enrolments of both sexes in Latin America(all income levels) in 1974 to that in 1977?
Offer a very short reply. 0.71. What is the ratio of the Number of enrolments of both sexes in Algeria in 1974 to that in 1977?
Your answer should be compact. 3.54. What is the ratio of the Number of enrolments of both sexes in El Salvador in 1974 to that in 1977?
Your answer should be very brief. 0.59. What is the ratio of the Number of enrolments of both sexes in Honduras in 1974 to that in 1977?
Provide a succinct answer. 0.68. What is the ratio of the Number of enrolments of both sexes of Latin America(all income levels) in 1975 to that in 1976?
Offer a terse response. 0.83. What is the ratio of the Number of enrolments of both sexes of Algeria in 1975 to that in 1976?
Keep it short and to the point. 1.07. What is the ratio of the Number of enrolments of both sexes in El Salvador in 1975 to that in 1976?
Provide a succinct answer. 0.83. What is the ratio of the Number of enrolments of both sexes in Honduras in 1975 to that in 1976?
Provide a short and direct response. 0.9. What is the ratio of the Number of enrolments of both sexes in Latin America(all income levels) in 1975 to that in 1977?
Provide a succinct answer. 0.76. What is the ratio of the Number of enrolments of both sexes in Algeria in 1975 to that in 1977?
Provide a short and direct response. 1.01. What is the ratio of the Number of enrolments of both sexes in El Salvador in 1975 to that in 1977?
Provide a short and direct response. 0.69. What is the ratio of the Number of enrolments of both sexes in Honduras in 1975 to that in 1977?
Provide a short and direct response. 0.79. What is the ratio of the Number of enrolments of both sexes in Latin America(all income levels) in 1976 to that in 1977?
Provide a succinct answer. 0.9. What is the ratio of the Number of enrolments of both sexes in Algeria in 1976 to that in 1977?
Provide a succinct answer. 0.94. What is the ratio of the Number of enrolments of both sexes in El Salvador in 1976 to that in 1977?
Make the answer very short. 0.83. What is the ratio of the Number of enrolments of both sexes in Honduras in 1976 to that in 1977?
Provide a short and direct response. 0.88. What is the difference between the highest and the second highest Number of enrolments of both sexes in Latin America(all income levels)?
Offer a terse response. 4.23e+05. What is the difference between the highest and the second highest Number of enrolments of both sexes of Algeria?
Your answer should be compact. 2.12e+04. What is the difference between the highest and the second highest Number of enrolments of both sexes of El Salvador?
Offer a very short reply. 5599. What is the difference between the highest and the second highest Number of enrolments of both sexes of Honduras?
Keep it short and to the point. 2913. What is the difference between the highest and the lowest Number of enrolments of both sexes of Latin America(all income levels)?
Your answer should be compact. 1.88e+06. What is the difference between the highest and the lowest Number of enrolments of both sexes of Algeria?
Make the answer very short. 5.99e+04. What is the difference between the highest and the lowest Number of enrolments of both sexes of El Salvador?
Provide a short and direct response. 1.76e+04. What is the difference between the highest and the lowest Number of enrolments of both sexes in Honduras?
Give a very brief answer. 1.33e+04. 